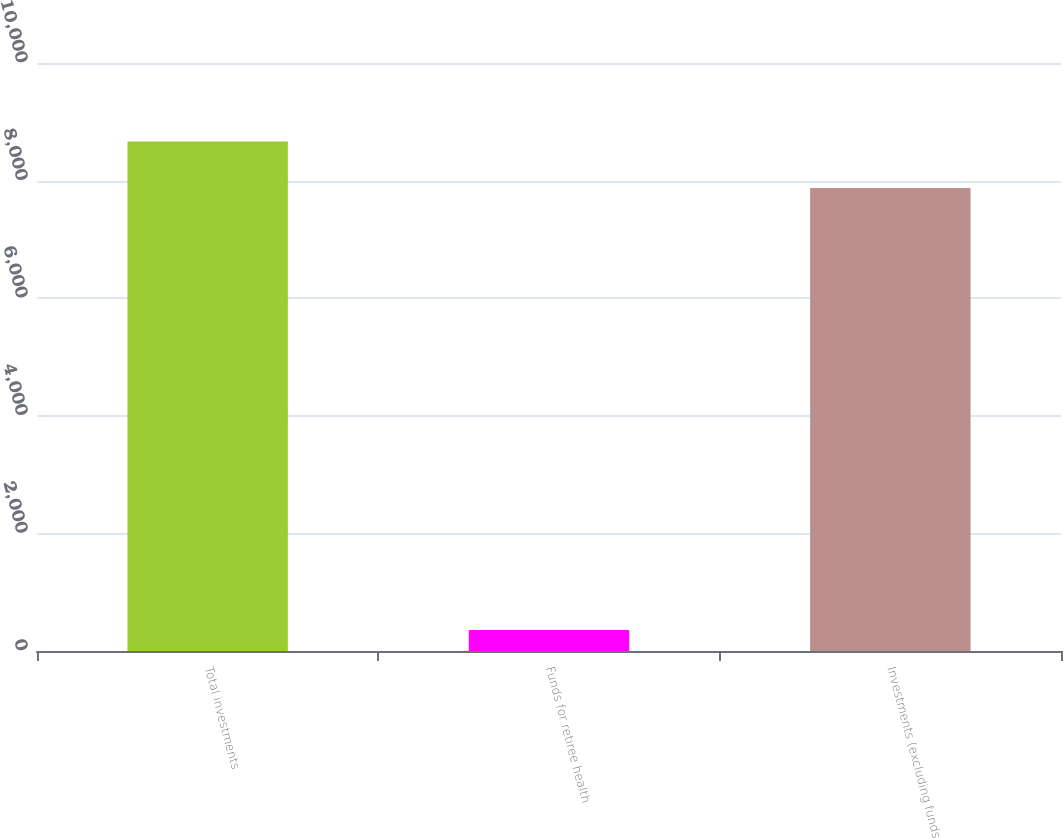<chart> <loc_0><loc_0><loc_500><loc_500><bar_chart><fcel>Total investments<fcel>Funds for retiree health<fcel>Investments (excluding funds<nl><fcel>8663.6<fcel>359<fcel>7876<nl></chart> 